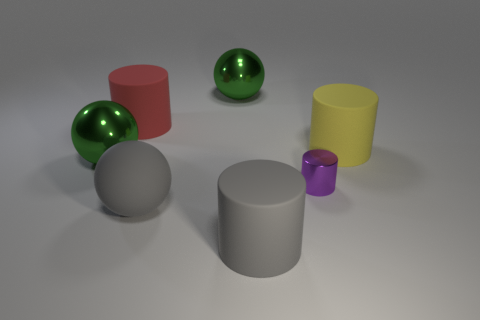How many green spheres must be subtracted to get 1 green spheres? 1 Subtract all red rubber cylinders. How many cylinders are left? 3 Add 1 purple matte balls. How many objects exist? 8 Subtract all gray cylinders. How many green spheres are left? 2 Subtract all gray cylinders. How many cylinders are left? 3 Subtract all balls. How many objects are left? 4 Subtract 1 cylinders. How many cylinders are left? 3 Subtract 0 brown cylinders. How many objects are left? 7 Subtract all green cylinders. Subtract all gray balls. How many cylinders are left? 4 Subtract all large gray things. Subtract all large yellow cylinders. How many objects are left? 4 